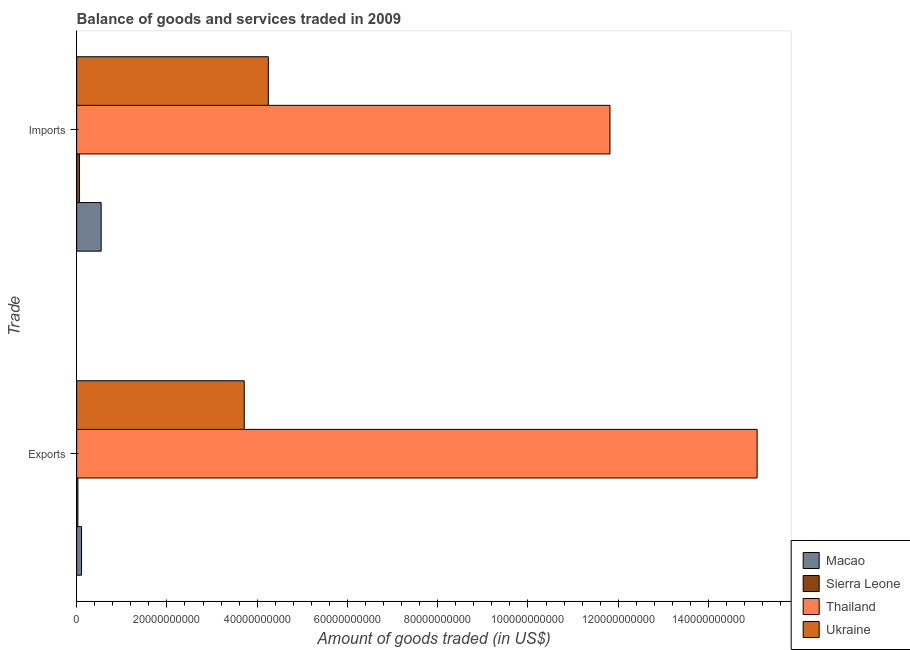Are the number of bars on each tick of the Y-axis equal?
Make the answer very short. Yes. How many bars are there on the 2nd tick from the bottom?
Your answer should be compact. 4. What is the label of the 1st group of bars from the top?
Provide a succinct answer. Imports. What is the amount of goods exported in Macao?
Make the answer very short. 1.09e+09. Across all countries, what is the maximum amount of goods imported?
Make the answer very short. 1.18e+11. Across all countries, what is the minimum amount of goods imported?
Your answer should be compact. 6.18e+08. In which country was the amount of goods exported maximum?
Provide a short and direct response. Thailand. In which country was the amount of goods exported minimum?
Make the answer very short. Sierra Leone. What is the total amount of goods imported in the graph?
Your response must be concise. 1.67e+11. What is the difference between the amount of goods imported in Thailand and that in Macao?
Make the answer very short. 1.13e+11. What is the difference between the amount of goods imported in Thailand and the amount of goods exported in Ukraine?
Keep it short and to the point. 8.10e+1. What is the average amount of goods imported per country?
Provide a succinct answer. 4.17e+1. What is the difference between the amount of goods exported and amount of goods imported in Ukraine?
Provide a short and direct response. -5.34e+09. In how many countries, is the amount of goods exported greater than 68000000000 US$?
Make the answer very short. 1. What is the ratio of the amount of goods exported in Sierra Leone to that in Macao?
Ensure brevity in your answer.  0.25. Is the amount of goods exported in Thailand less than that in Macao?
Ensure brevity in your answer.  No. What does the 1st bar from the top in Imports represents?
Provide a short and direct response. Ukraine. What does the 3rd bar from the bottom in Imports represents?
Provide a short and direct response. Thailand. How many bars are there?
Give a very brief answer. 8. Are all the bars in the graph horizontal?
Make the answer very short. Yes. How many countries are there in the graph?
Offer a terse response. 4. What is the difference between two consecutive major ticks on the X-axis?
Make the answer very short. 2.00e+1. Are the values on the major ticks of X-axis written in scientific E-notation?
Your answer should be very brief. No. Does the graph contain any zero values?
Offer a very short reply. No. What is the title of the graph?
Ensure brevity in your answer.  Balance of goods and services traded in 2009. Does "American Samoa" appear as one of the legend labels in the graph?
Offer a terse response. No. What is the label or title of the X-axis?
Your answer should be compact. Amount of goods traded (in US$). What is the label or title of the Y-axis?
Give a very brief answer. Trade. What is the Amount of goods traded (in US$) of Macao in Exports?
Keep it short and to the point. 1.09e+09. What is the Amount of goods traded (in US$) in Sierra Leone in Exports?
Ensure brevity in your answer.  2.68e+08. What is the Amount of goods traded (in US$) of Thailand in Exports?
Offer a terse response. 1.51e+11. What is the Amount of goods traded (in US$) of Ukraine in Exports?
Provide a short and direct response. 3.71e+1. What is the Amount of goods traded (in US$) in Macao in Imports?
Keep it short and to the point. 5.43e+09. What is the Amount of goods traded (in US$) of Sierra Leone in Imports?
Ensure brevity in your answer.  6.18e+08. What is the Amount of goods traded (in US$) of Thailand in Imports?
Your response must be concise. 1.18e+11. What is the Amount of goods traded (in US$) in Ukraine in Imports?
Give a very brief answer. 4.25e+1. Across all Trade, what is the maximum Amount of goods traded (in US$) of Macao?
Keep it short and to the point. 5.43e+09. Across all Trade, what is the maximum Amount of goods traded (in US$) of Sierra Leone?
Make the answer very short. 6.18e+08. Across all Trade, what is the maximum Amount of goods traded (in US$) in Thailand?
Offer a very short reply. 1.51e+11. Across all Trade, what is the maximum Amount of goods traded (in US$) of Ukraine?
Your answer should be compact. 4.25e+1. Across all Trade, what is the minimum Amount of goods traded (in US$) of Macao?
Your response must be concise. 1.09e+09. Across all Trade, what is the minimum Amount of goods traded (in US$) in Sierra Leone?
Keep it short and to the point. 2.68e+08. Across all Trade, what is the minimum Amount of goods traded (in US$) in Thailand?
Give a very brief answer. 1.18e+11. Across all Trade, what is the minimum Amount of goods traded (in US$) in Ukraine?
Provide a short and direct response. 3.71e+1. What is the total Amount of goods traded (in US$) in Macao in the graph?
Provide a short and direct response. 6.51e+09. What is the total Amount of goods traded (in US$) in Sierra Leone in the graph?
Provide a short and direct response. 8.85e+08. What is the total Amount of goods traded (in US$) in Thailand in the graph?
Your answer should be compact. 2.69e+11. What is the total Amount of goods traded (in US$) in Ukraine in the graph?
Give a very brief answer. 7.96e+1. What is the difference between the Amount of goods traded (in US$) of Macao in Exports and that in Imports?
Your response must be concise. -4.34e+09. What is the difference between the Amount of goods traded (in US$) of Sierra Leone in Exports and that in Imports?
Provide a succinct answer. -3.50e+08. What is the difference between the Amount of goods traded (in US$) in Thailand in Exports and that in Imports?
Offer a terse response. 3.26e+1. What is the difference between the Amount of goods traded (in US$) of Ukraine in Exports and that in Imports?
Ensure brevity in your answer.  -5.34e+09. What is the difference between the Amount of goods traded (in US$) of Macao in Exports and the Amount of goods traded (in US$) of Sierra Leone in Imports?
Your answer should be very brief. 4.69e+08. What is the difference between the Amount of goods traded (in US$) in Macao in Exports and the Amount of goods traded (in US$) in Thailand in Imports?
Offer a terse response. -1.17e+11. What is the difference between the Amount of goods traded (in US$) in Macao in Exports and the Amount of goods traded (in US$) in Ukraine in Imports?
Give a very brief answer. -4.14e+1. What is the difference between the Amount of goods traded (in US$) in Sierra Leone in Exports and the Amount of goods traded (in US$) in Thailand in Imports?
Provide a short and direct response. -1.18e+11. What is the difference between the Amount of goods traded (in US$) in Sierra Leone in Exports and the Amount of goods traded (in US$) in Ukraine in Imports?
Keep it short and to the point. -4.22e+1. What is the difference between the Amount of goods traded (in US$) of Thailand in Exports and the Amount of goods traded (in US$) of Ukraine in Imports?
Keep it short and to the point. 1.08e+11. What is the average Amount of goods traded (in US$) of Macao per Trade?
Provide a succinct answer. 3.26e+09. What is the average Amount of goods traded (in US$) of Sierra Leone per Trade?
Make the answer very short. 4.43e+08. What is the average Amount of goods traded (in US$) of Thailand per Trade?
Offer a very short reply. 1.34e+11. What is the average Amount of goods traded (in US$) in Ukraine per Trade?
Your answer should be compact. 3.98e+1. What is the difference between the Amount of goods traded (in US$) in Macao and Amount of goods traded (in US$) in Sierra Leone in Exports?
Give a very brief answer. 8.19e+08. What is the difference between the Amount of goods traded (in US$) in Macao and Amount of goods traded (in US$) in Thailand in Exports?
Give a very brief answer. -1.50e+11. What is the difference between the Amount of goods traded (in US$) of Macao and Amount of goods traded (in US$) of Ukraine in Exports?
Your answer should be compact. -3.60e+1. What is the difference between the Amount of goods traded (in US$) in Sierra Leone and Amount of goods traded (in US$) in Thailand in Exports?
Keep it short and to the point. -1.51e+11. What is the difference between the Amount of goods traded (in US$) in Sierra Leone and Amount of goods traded (in US$) in Ukraine in Exports?
Offer a very short reply. -3.69e+1. What is the difference between the Amount of goods traded (in US$) of Thailand and Amount of goods traded (in US$) of Ukraine in Exports?
Your answer should be very brief. 1.14e+11. What is the difference between the Amount of goods traded (in US$) in Macao and Amount of goods traded (in US$) in Sierra Leone in Imports?
Your answer should be compact. 4.81e+09. What is the difference between the Amount of goods traded (in US$) of Macao and Amount of goods traded (in US$) of Thailand in Imports?
Your response must be concise. -1.13e+11. What is the difference between the Amount of goods traded (in US$) in Macao and Amount of goods traded (in US$) in Ukraine in Imports?
Provide a short and direct response. -3.71e+1. What is the difference between the Amount of goods traded (in US$) of Sierra Leone and Amount of goods traded (in US$) of Thailand in Imports?
Provide a succinct answer. -1.18e+11. What is the difference between the Amount of goods traded (in US$) of Sierra Leone and Amount of goods traded (in US$) of Ukraine in Imports?
Offer a very short reply. -4.19e+1. What is the difference between the Amount of goods traded (in US$) of Thailand and Amount of goods traded (in US$) of Ukraine in Imports?
Ensure brevity in your answer.  7.57e+1. What is the ratio of the Amount of goods traded (in US$) in Macao in Exports to that in Imports?
Your answer should be compact. 0.2. What is the ratio of the Amount of goods traded (in US$) of Sierra Leone in Exports to that in Imports?
Your answer should be compact. 0.43. What is the ratio of the Amount of goods traded (in US$) in Thailand in Exports to that in Imports?
Give a very brief answer. 1.28. What is the ratio of the Amount of goods traded (in US$) in Ukraine in Exports to that in Imports?
Give a very brief answer. 0.87. What is the difference between the highest and the second highest Amount of goods traded (in US$) in Macao?
Make the answer very short. 4.34e+09. What is the difference between the highest and the second highest Amount of goods traded (in US$) of Sierra Leone?
Offer a terse response. 3.50e+08. What is the difference between the highest and the second highest Amount of goods traded (in US$) in Thailand?
Offer a terse response. 3.26e+1. What is the difference between the highest and the second highest Amount of goods traded (in US$) in Ukraine?
Give a very brief answer. 5.34e+09. What is the difference between the highest and the lowest Amount of goods traded (in US$) of Macao?
Your response must be concise. 4.34e+09. What is the difference between the highest and the lowest Amount of goods traded (in US$) of Sierra Leone?
Give a very brief answer. 3.50e+08. What is the difference between the highest and the lowest Amount of goods traded (in US$) of Thailand?
Your answer should be very brief. 3.26e+1. What is the difference between the highest and the lowest Amount of goods traded (in US$) of Ukraine?
Offer a terse response. 5.34e+09. 